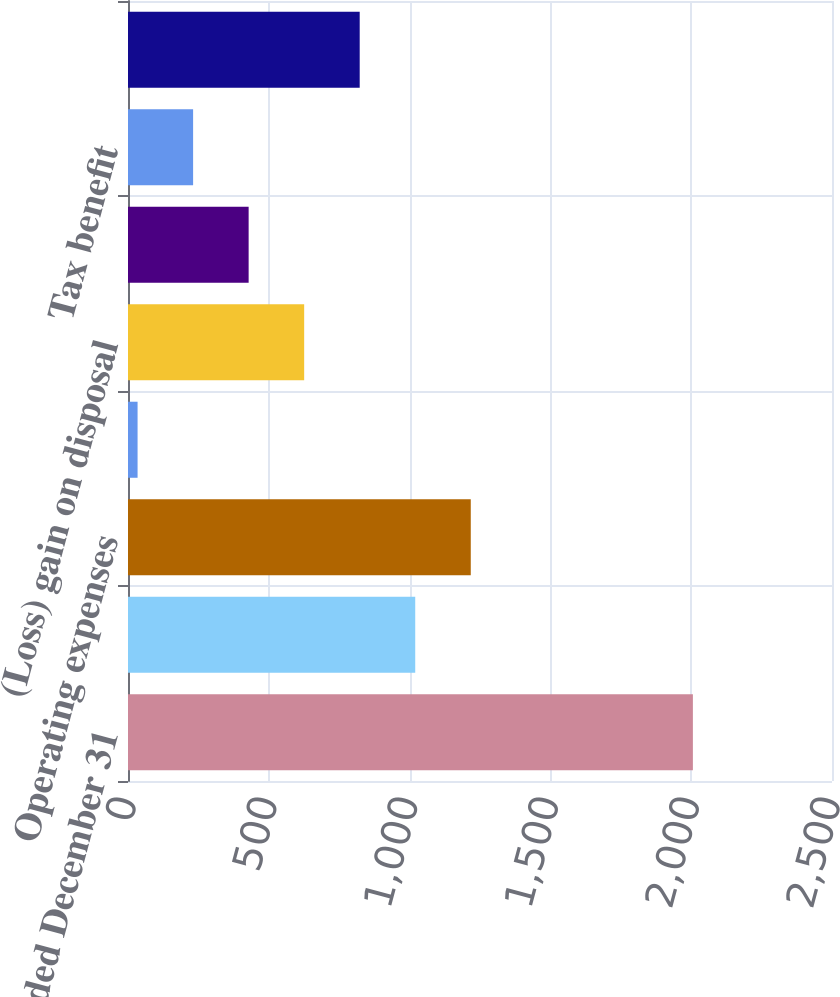<chart> <loc_0><loc_0><loc_500><loc_500><bar_chart><fcel>Year Ended December 31<fcel>Net sales<fcel>Operating expenses<fcel>Operating loss<fcel>(Loss) gain on disposal<fcel>(Loss) earnings before taxes<fcel>Tax benefit<fcel>(Loss) earnings from<nl><fcel>2006<fcel>1020<fcel>1217.2<fcel>34<fcel>625.6<fcel>428.4<fcel>231.2<fcel>822.8<nl></chart> 